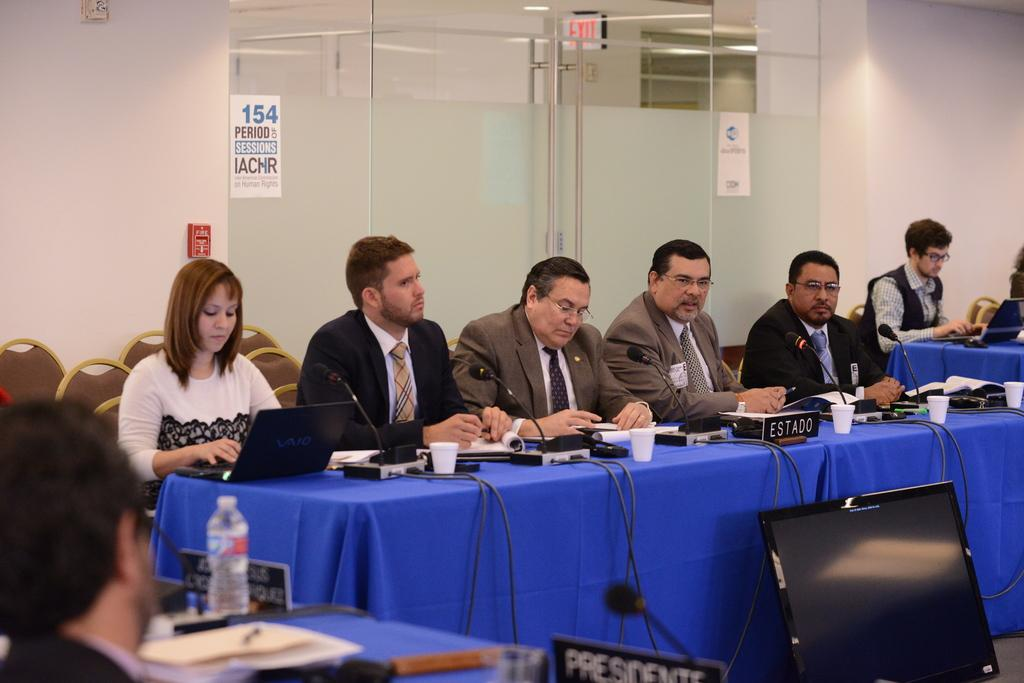<image>
Write a terse but informative summary of the picture. Several people sit at a table the man at the center of which is Estado, 